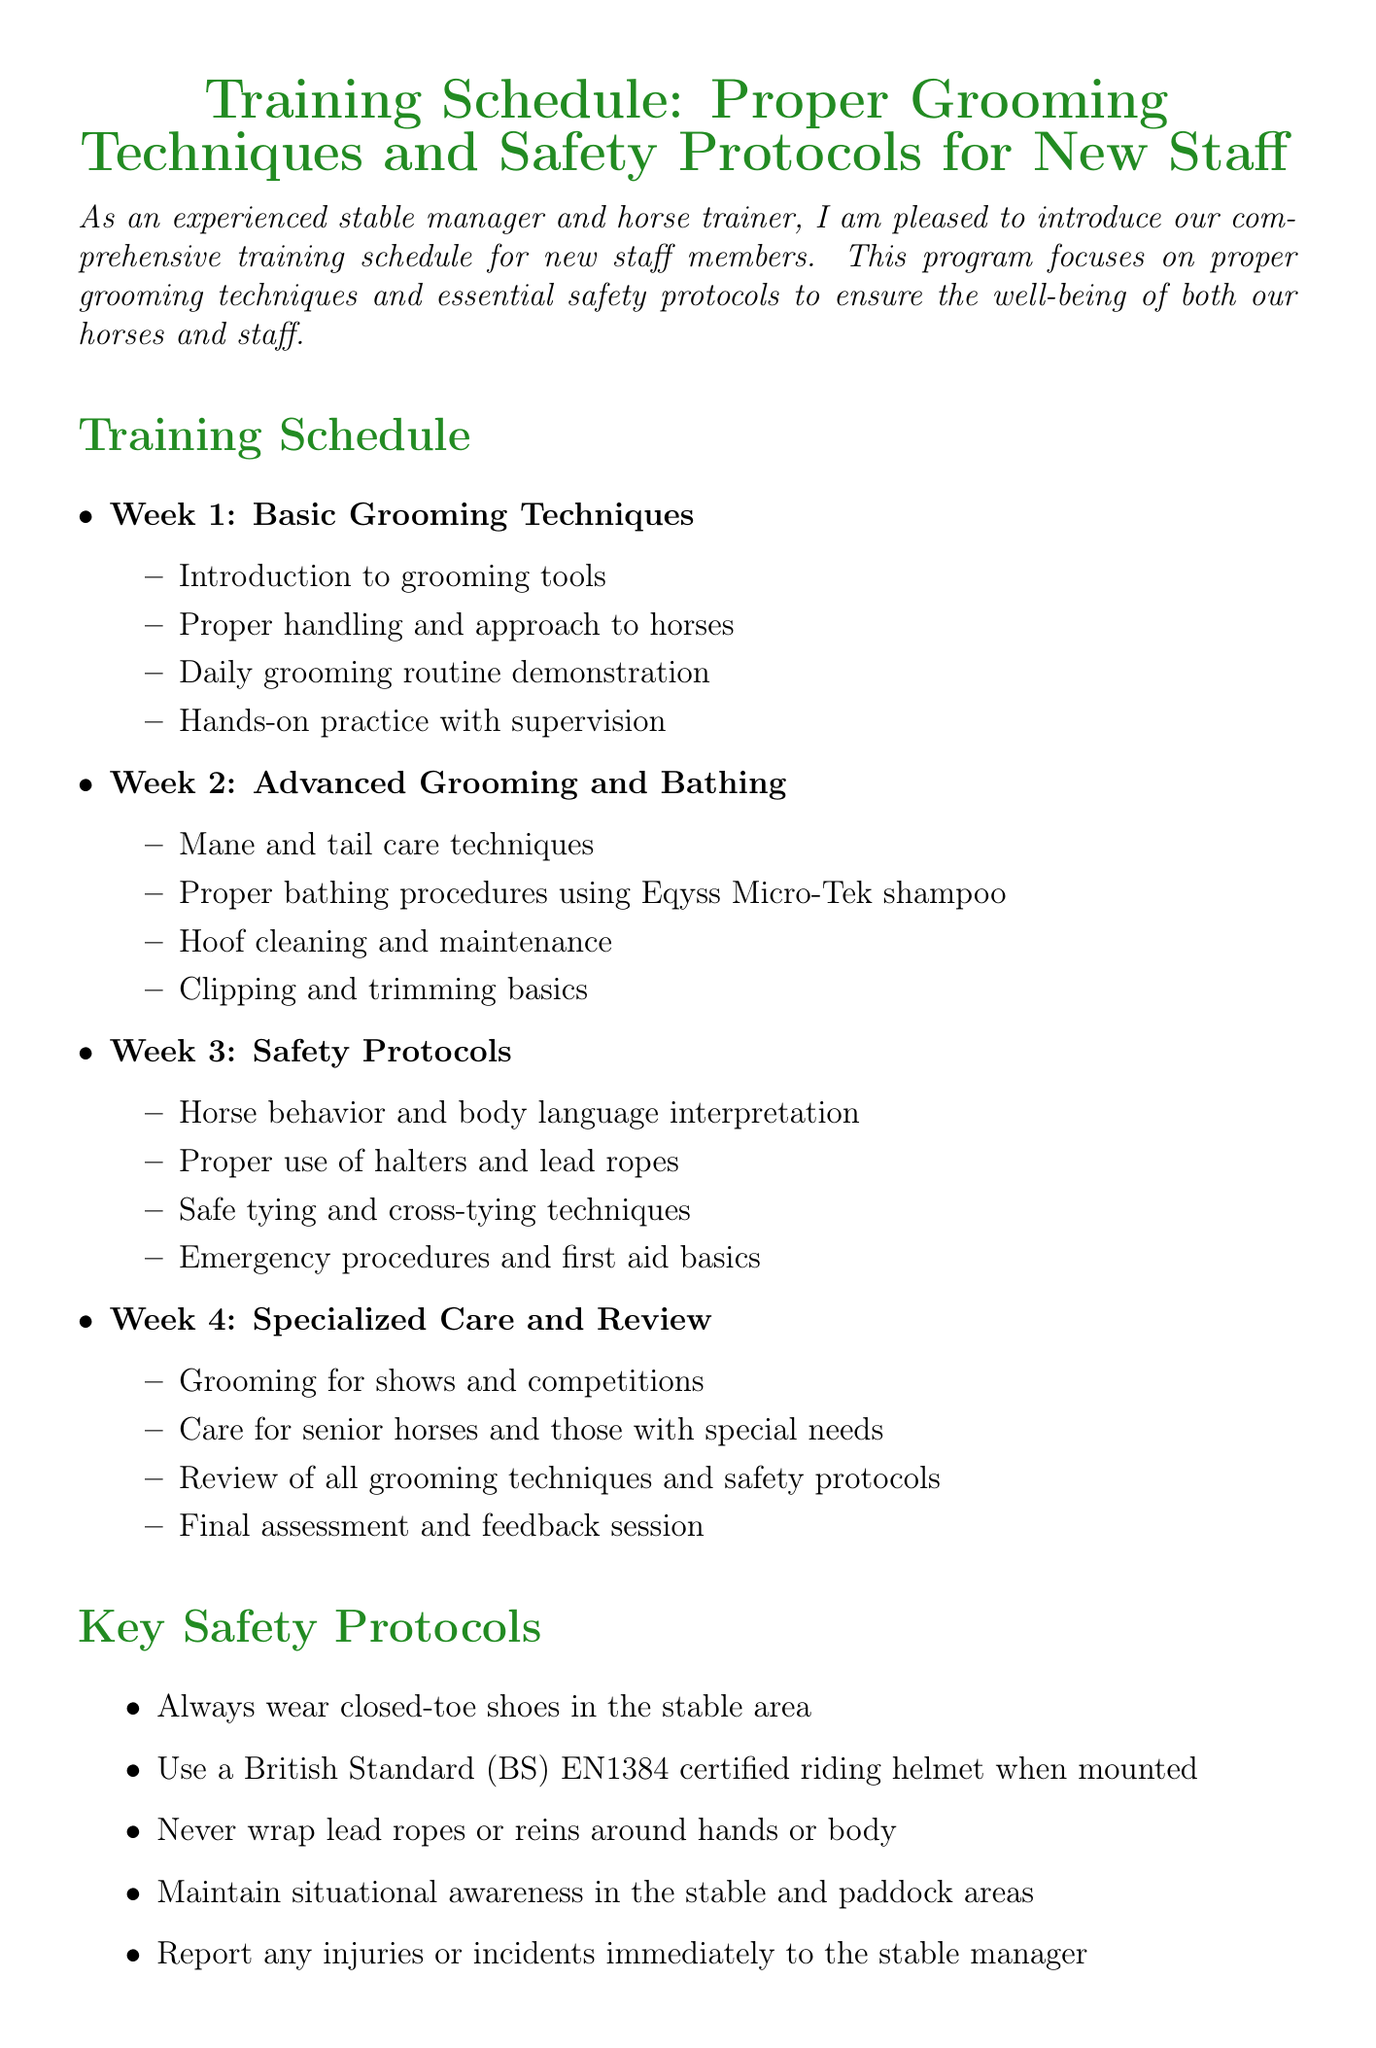What is the title of the memo? The title of the memo is stated at the beginning of the document.
Answer: Training Schedule: Proper Grooming Techniques and Safety Protocols for New Staff Who is the mentor contact? The mentor contact is specified towards the end of the document, including the person's name and title.
Answer: Sarah Thompson What is the location of the training? The training location is detailed after the safety protocols section.
Answer: Sunny Meadow Stables, 1234 Equestrian Way, Lexington, KY 40511 How many weeks is the training schedule? The document outlines a training schedule spanning several weeks.
Answer: 4 What grooming tool is recommended for hoof care? The document lists recommended grooming tools for proper care, including specific items for hoof care.
Answer: Tough-1 Great Grip Hoof Pick During which week is safety protocols covered? The week in which safety protocols are addressed can be found in the training schedule.
Answer: Week 3 What is one of the key safety protocols? Key safety protocols are listed and explained within the document.
Answer: Always wear closed-toe shoes in the stable area What is the focus of week 2 in the training schedule? The focus for each week is explicitly detailed in the training schedule section.
Answer: Advanced Grooming and Bathing What is emphasized as key to becoming proficient in horse care? The document concludes with an important message about the training.
Answer: Consistent practice and attention to detail 